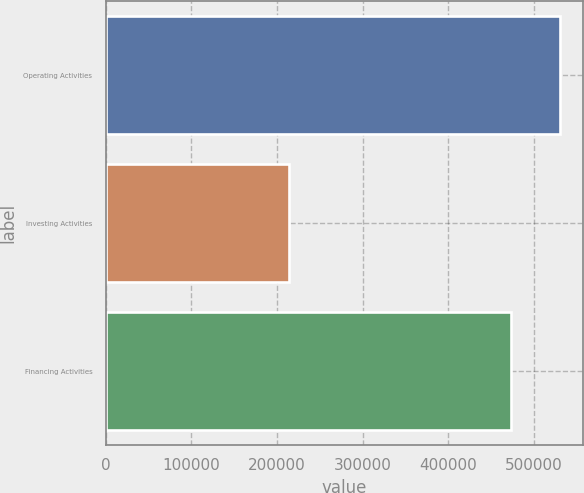Convert chart to OTSL. <chart><loc_0><loc_0><loc_500><loc_500><bar_chart><fcel>Operating Activities<fcel>Investing Activities<fcel>Financing Activities<nl><fcel>530309<fcel>214334<fcel>472573<nl></chart> 